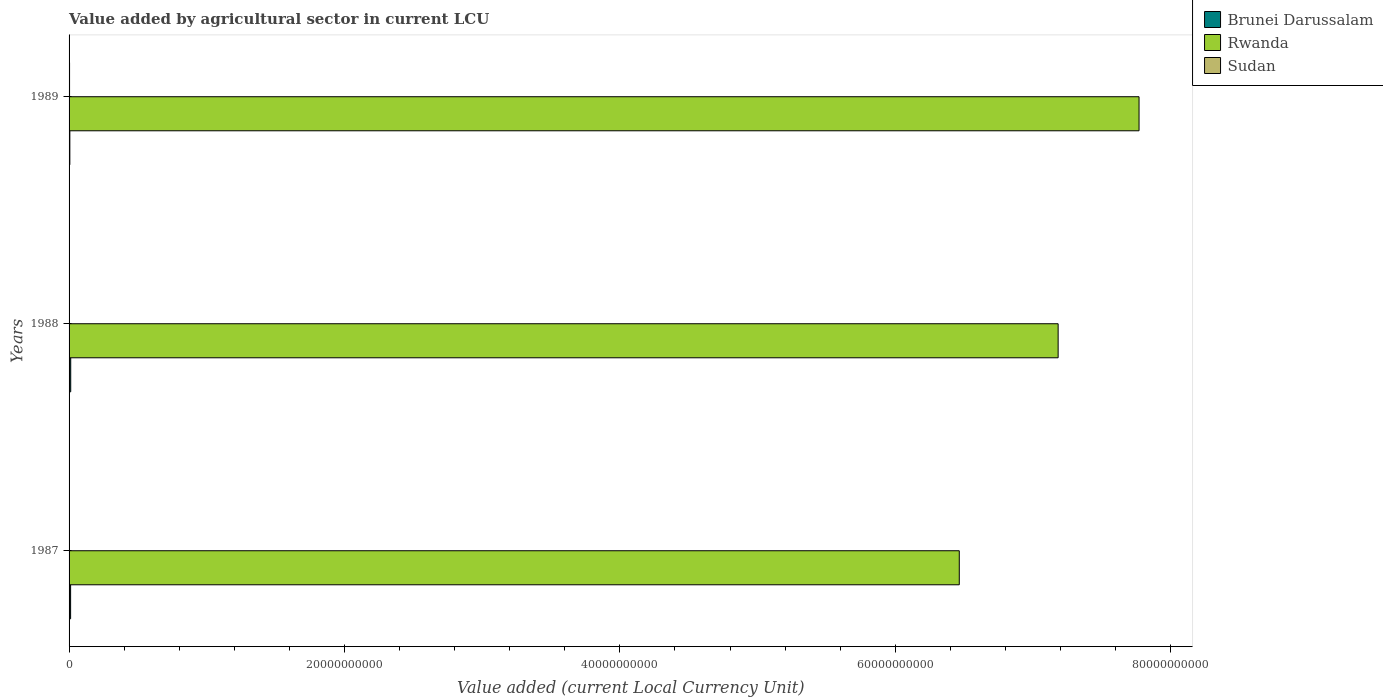How many different coloured bars are there?
Give a very brief answer. 3. How many groups of bars are there?
Your answer should be compact. 3. Are the number of bars on each tick of the Y-axis equal?
Your answer should be very brief. Yes. How many bars are there on the 3rd tick from the bottom?
Ensure brevity in your answer.  3. What is the label of the 2nd group of bars from the top?
Provide a succinct answer. 1988. What is the value added by agricultural sector in Rwanda in 1987?
Make the answer very short. 6.46e+1. Across all years, what is the maximum value added by agricultural sector in Rwanda?
Provide a succinct answer. 7.77e+1. Across all years, what is the minimum value added by agricultural sector in Sudan?
Ensure brevity in your answer.  1.15e+07. In which year was the value added by agricultural sector in Rwanda maximum?
Provide a succinct answer. 1989. In which year was the value added by agricultural sector in Sudan minimum?
Keep it short and to the point. 1987. What is the total value added by agricultural sector in Sudan in the graph?
Make the answer very short. 7.29e+07. What is the difference between the value added by agricultural sector in Rwanda in 1987 and that in 1988?
Offer a very short reply. -7.18e+09. What is the difference between the value added by agricultural sector in Sudan in 1987 and the value added by agricultural sector in Brunei Darussalam in 1988?
Your answer should be very brief. -1.09e+08. What is the average value added by agricultural sector in Sudan per year?
Provide a short and direct response. 2.43e+07. In the year 1988, what is the difference between the value added by agricultural sector in Rwanda and value added by agricultural sector in Sudan?
Provide a succinct answer. 7.18e+1. In how many years, is the value added by agricultural sector in Brunei Darussalam greater than 64000000000 LCU?
Provide a short and direct response. 0. What is the ratio of the value added by agricultural sector in Sudan in 1988 to that in 1989?
Offer a very short reply. 0.71. What is the difference between the highest and the second highest value added by agricultural sector in Rwanda?
Your answer should be compact. 5.87e+09. What is the difference between the highest and the lowest value added by agricultural sector in Sudan?
Your answer should be very brief. 2.45e+07. In how many years, is the value added by agricultural sector in Sudan greater than the average value added by agricultural sector in Sudan taken over all years?
Provide a short and direct response. 2. Is the sum of the value added by agricultural sector in Sudan in 1987 and 1989 greater than the maximum value added by agricultural sector in Rwanda across all years?
Give a very brief answer. No. What does the 3rd bar from the top in 1987 represents?
Offer a terse response. Brunei Darussalam. What does the 2nd bar from the bottom in 1989 represents?
Offer a very short reply. Rwanda. Are all the bars in the graph horizontal?
Your answer should be compact. Yes. Are the values on the major ticks of X-axis written in scientific E-notation?
Provide a succinct answer. No. Does the graph contain grids?
Provide a short and direct response. No. How are the legend labels stacked?
Offer a very short reply. Vertical. What is the title of the graph?
Offer a terse response. Value added by agricultural sector in current LCU. What is the label or title of the X-axis?
Your response must be concise. Value added (current Local Currency Unit). What is the Value added (current Local Currency Unit) in Brunei Darussalam in 1987?
Provide a succinct answer. 1.12e+08. What is the Value added (current Local Currency Unit) of Rwanda in 1987?
Offer a very short reply. 6.46e+1. What is the Value added (current Local Currency Unit) of Sudan in 1987?
Give a very brief answer. 1.15e+07. What is the Value added (current Local Currency Unit) of Brunei Darussalam in 1988?
Make the answer very short. 1.20e+08. What is the Value added (current Local Currency Unit) in Rwanda in 1988?
Provide a short and direct response. 7.18e+1. What is the Value added (current Local Currency Unit) in Sudan in 1988?
Ensure brevity in your answer.  2.55e+07. What is the Value added (current Local Currency Unit) in Brunei Darussalam in 1989?
Offer a terse response. 5.60e+07. What is the Value added (current Local Currency Unit) in Rwanda in 1989?
Provide a succinct answer. 7.77e+1. What is the Value added (current Local Currency Unit) in Sudan in 1989?
Ensure brevity in your answer.  3.60e+07. Across all years, what is the maximum Value added (current Local Currency Unit) in Brunei Darussalam?
Provide a succinct answer. 1.20e+08. Across all years, what is the maximum Value added (current Local Currency Unit) in Rwanda?
Provide a succinct answer. 7.77e+1. Across all years, what is the maximum Value added (current Local Currency Unit) of Sudan?
Offer a very short reply. 3.60e+07. Across all years, what is the minimum Value added (current Local Currency Unit) in Brunei Darussalam?
Provide a short and direct response. 5.60e+07. Across all years, what is the minimum Value added (current Local Currency Unit) of Rwanda?
Your answer should be compact. 6.46e+1. Across all years, what is the minimum Value added (current Local Currency Unit) of Sudan?
Make the answer very short. 1.15e+07. What is the total Value added (current Local Currency Unit) of Brunei Darussalam in the graph?
Make the answer very short. 2.88e+08. What is the total Value added (current Local Currency Unit) of Rwanda in the graph?
Ensure brevity in your answer.  2.14e+11. What is the total Value added (current Local Currency Unit) of Sudan in the graph?
Provide a succinct answer. 7.29e+07. What is the difference between the Value added (current Local Currency Unit) of Brunei Darussalam in 1987 and that in 1988?
Provide a short and direct response. -8.00e+06. What is the difference between the Value added (current Local Currency Unit) of Rwanda in 1987 and that in 1988?
Keep it short and to the point. -7.18e+09. What is the difference between the Value added (current Local Currency Unit) of Sudan in 1987 and that in 1988?
Give a very brief answer. -1.40e+07. What is the difference between the Value added (current Local Currency Unit) in Brunei Darussalam in 1987 and that in 1989?
Keep it short and to the point. 5.60e+07. What is the difference between the Value added (current Local Currency Unit) in Rwanda in 1987 and that in 1989?
Give a very brief answer. -1.31e+1. What is the difference between the Value added (current Local Currency Unit) in Sudan in 1987 and that in 1989?
Your answer should be very brief. -2.45e+07. What is the difference between the Value added (current Local Currency Unit) in Brunei Darussalam in 1988 and that in 1989?
Ensure brevity in your answer.  6.40e+07. What is the difference between the Value added (current Local Currency Unit) of Rwanda in 1988 and that in 1989?
Offer a terse response. -5.87e+09. What is the difference between the Value added (current Local Currency Unit) in Sudan in 1988 and that in 1989?
Make the answer very short. -1.05e+07. What is the difference between the Value added (current Local Currency Unit) of Brunei Darussalam in 1987 and the Value added (current Local Currency Unit) of Rwanda in 1988?
Your answer should be very brief. -7.17e+1. What is the difference between the Value added (current Local Currency Unit) in Brunei Darussalam in 1987 and the Value added (current Local Currency Unit) in Sudan in 1988?
Your answer should be very brief. 8.65e+07. What is the difference between the Value added (current Local Currency Unit) in Rwanda in 1987 and the Value added (current Local Currency Unit) in Sudan in 1988?
Provide a succinct answer. 6.46e+1. What is the difference between the Value added (current Local Currency Unit) in Brunei Darussalam in 1987 and the Value added (current Local Currency Unit) in Rwanda in 1989?
Keep it short and to the point. -7.76e+1. What is the difference between the Value added (current Local Currency Unit) in Brunei Darussalam in 1987 and the Value added (current Local Currency Unit) in Sudan in 1989?
Make the answer very short. 7.60e+07. What is the difference between the Value added (current Local Currency Unit) of Rwanda in 1987 and the Value added (current Local Currency Unit) of Sudan in 1989?
Your answer should be compact. 6.46e+1. What is the difference between the Value added (current Local Currency Unit) in Brunei Darussalam in 1988 and the Value added (current Local Currency Unit) in Rwanda in 1989?
Provide a short and direct response. -7.76e+1. What is the difference between the Value added (current Local Currency Unit) in Brunei Darussalam in 1988 and the Value added (current Local Currency Unit) in Sudan in 1989?
Offer a very short reply. 8.40e+07. What is the difference between the Value added (current Local Currency Unit) in Rwanda in 1988 and the Value added (current Local Currency Unit) in Sudan in 1989?
Make the answer very short. 7.18e+1. What is the average Value added (current Local Currency Unit) of Brunei Darussalam per year?
Offer a terse response. 9.60e+07. What is the average Value added (current Local Currency Unit) in Rwanda per year?
Provide a succinct answer. 7.14e+1. What is the average Value added (current Local Currency Unit) in Sudan per year?
Your answer should be compact. 2.43e+07. In the year 1987, what is the difference between the Value added (current Local Currency Unit) in Brunei Darussalam and Value added (current Local Currency Unit) in Rwanda?
Your answer should be very brief. -6.45e+1. In the year 1987, what is the difference between the Value added (current Local Currency Unit) in Brunei Darussalam and Value added (current Local Currency Unit) in Sudan?
Offer a very short reply. 1.01e+08. In the year 1987, what is the difference between the Value added (current Local Currency Unit) of Rwanda and Value added (current Local Currency Unit) of Sudan?
Provide a short and direct response. 6.46e+1. In the year 1988, what is the difference between the Value added (current Local Currency Unit) of Brunei Darussalam and Value added (current Local Currency Unit) of Rwanda?
Provide a succinct answer. -7.17e+1. In the year 1988, what is the difference between the Value added (current Local Currency Unit) in Brunei Darussalam and Value added (current Local Currency Unit) in Sudan?
Your answer should be compact. 9.45e+07. In the year 1988, what is the difference between the Value added (current Local Currency Unit) of Rwanda and Value added (current Local Currency Unit) of Sudan?
Offer a terse response. 7.18e+1. In the year 1989, what is the difference between the Value added (current Local Currency Unit) in Brunei Darussalam and Value added (current Local Currency Unit) in Rwanda?
Keep it short and to the point. -7.76e+1. In the year 1989, what is the difference between the Value added (current Local Currency Unit) of Brunei Darussalam and Value added (current Local Currency Unit) of Sudan?
Provide a short and direct response. 2.00e+07. In the year 1989, what is the difference between the Value added (current Local Currency Unit) in Rwanda and Value added (current Local Currency Unit) in Sudan?
Provide a short and direct response. 7.77e+1. What is the ratio of the Value added (current Local Currency Unit) in Sudan in 1987 to that in 1988?
Ensure brevity in your answer.  0.45. What is the ratio of the Value added (current Local Currency Unit) in Brunei Darussalam in 1987 to that in 1989?
Give a very brief answer. 2. What is the ratio of the Value added (current Local Currency Unit) in Rwanda in 1987 to that in 1989?
Keep it short and to the point. 0.83. What is the ratio of the Value added (current Local Currency Unit) of Sudan in 1987 to that in 1989?
Provide a short and direct response. 0.32. What is the ratio of the Value added (current Local Currency Unit) in Brunei Darussalam in 1988 to that in 1989?
Provide a short and direct response. 2.14. What is the ratio of the Value added (current Local Currency Unit) in Rwanda in 1988 to that in 1989?
Your answer should be compact. 0.92. What is the ratio of the Value added (current Local Currency Unit) of Sudan in 1988 to that in 1989?
Make the answer very short. 0.71. What is the difference between the highest and the second highest Value added (current Local Currency Unit) of Brunei Darussalam?
Keep it short and to the point. 8.00e+06. What is the difference between the highest and the second highest Value added (current Local Currency Unit) in Rwanda?
Make the answer very short. 5.87e+09. What is the difference between the highest and the second highest Value added (current Local Currency Unit) of Sudan?
Make the answer very short. 1.05e+07. What is the difference between the highest and the lowest Value added (current Local Currency Unit) in Brunei Darussalam?
Provide a short and direct response. 6.40e+07. What is the difference between the highest and the lowest Value added (current Local Currency Unit) of Rwanda?
Give a very brief answer. 1.31e+1. What is the difference between the highest and the lowest Value added (current Local Currency Unit) of Sudan?
Offer a terse response. 2.45e+07. 